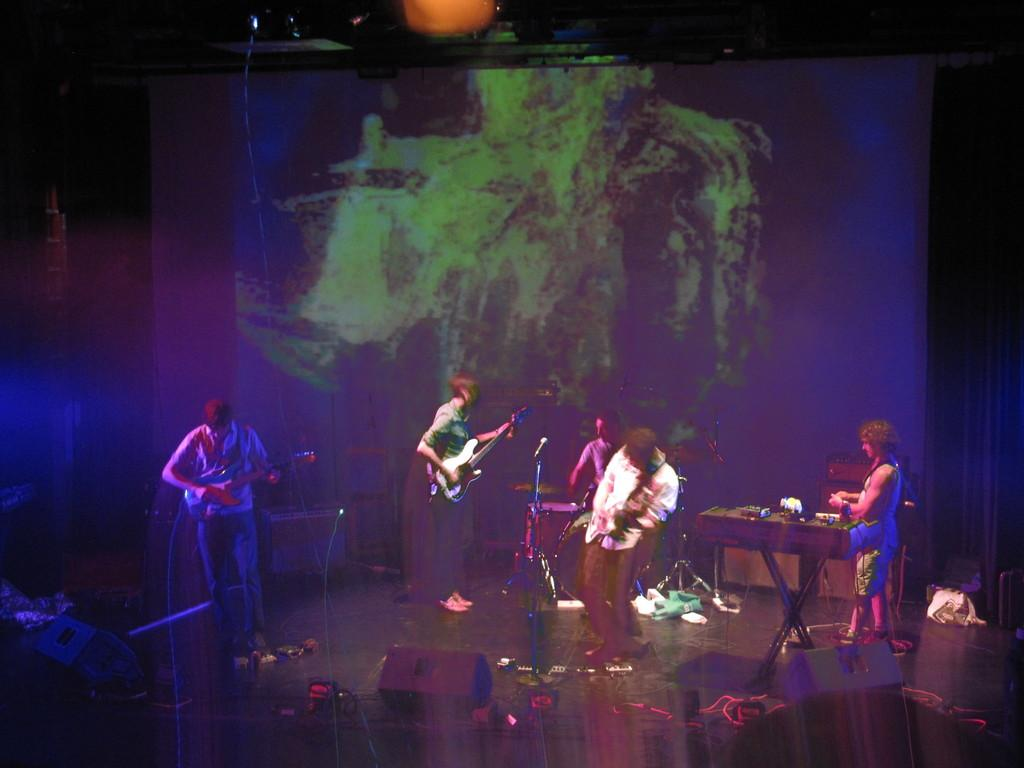What are the people in the image doing? There are three persons standing and playing a guitar, and one person is sitting and playing drums. Is there anyone else involved in the music-making? Yes, there is a man standing near a piano. What can be seen in the background of the image? There is a screen in the background. Can you tell me how many jellyfish are swimming on the piano in the image? There are no jellyfish present in the image, and they are not swimming on the piano. What type of support is the man using to play the piano in the image? The man is not using any visible support to play the piano in the image. 